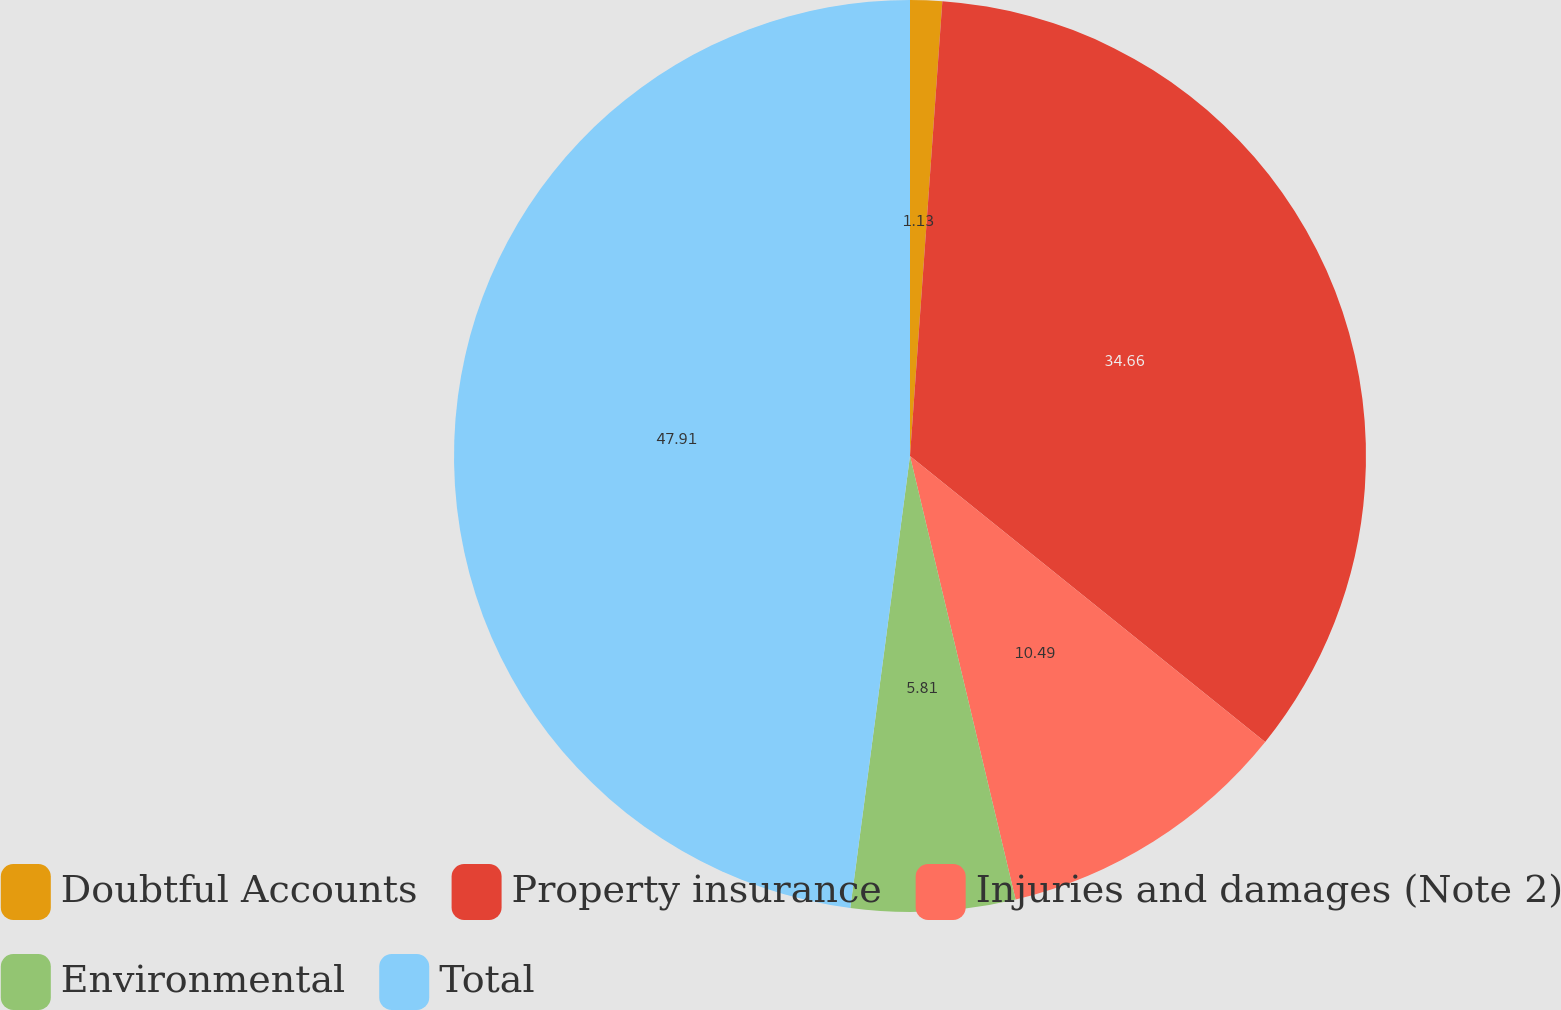Convert chart to OTSL. <chart><loc_0><loc_0><loc_500><loc_500><pie_chart><fcel>Doubtful Accounts<fcel>Property insurance<fcel>Injuries and damages (Note 2)<fcel>Environmental<fcel>Total<nl><fcel>1.13%<fcel>34.66%<fcel>10.49%<fcel>5.81%<fcel>47.91%<nl></chart> 